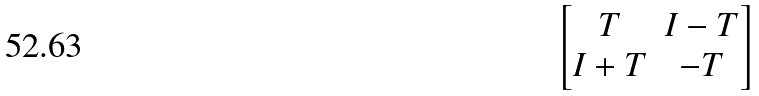<formula> <loc_0><loc_0><loc_500><loc_500>\begin{bmatrix} T & I - T \\ I + T & - T \end{bmatrix}</formula> 